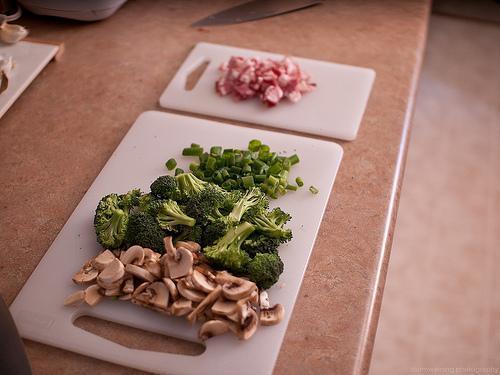How many cutting boards are in the picture?
Give a very brief answer. 2. 